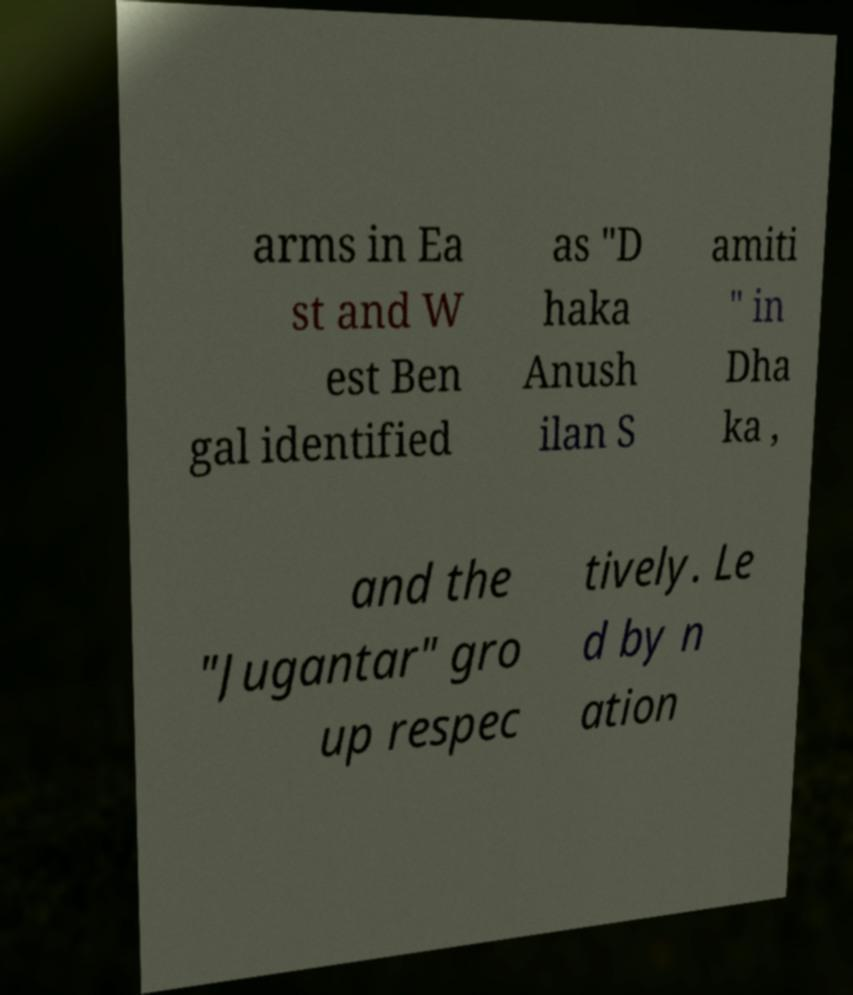Can you accurately transcribe the text from the provided image for me? arms in Ea st and W est Ben gal identified as "D haka Anush ilan S amiti " in Dha ka , and the "Jugantar" gro up respec tively. Le d by n ation 